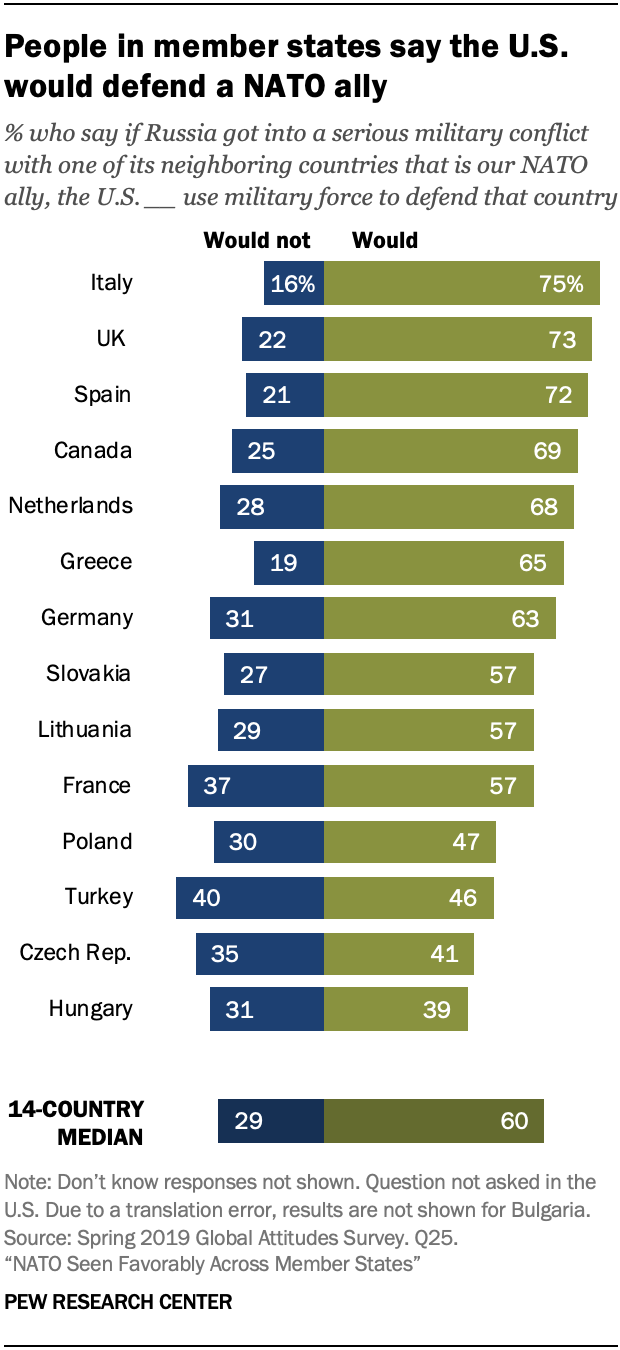Identify some key points in this picture. The median of the people in member states who say the US would not defend a NATO ally is 0.48, and the median of the people in member states who say the US would defend a NATO ally is 0.52. The representation of the bars utilizes two colors, namely blue and green. 